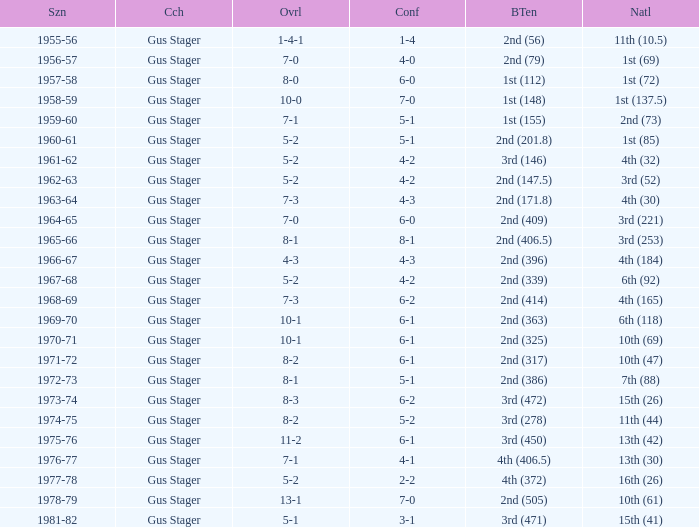What is the Coach with a Big Ten that is 3rd (278)? Gus Stager. 